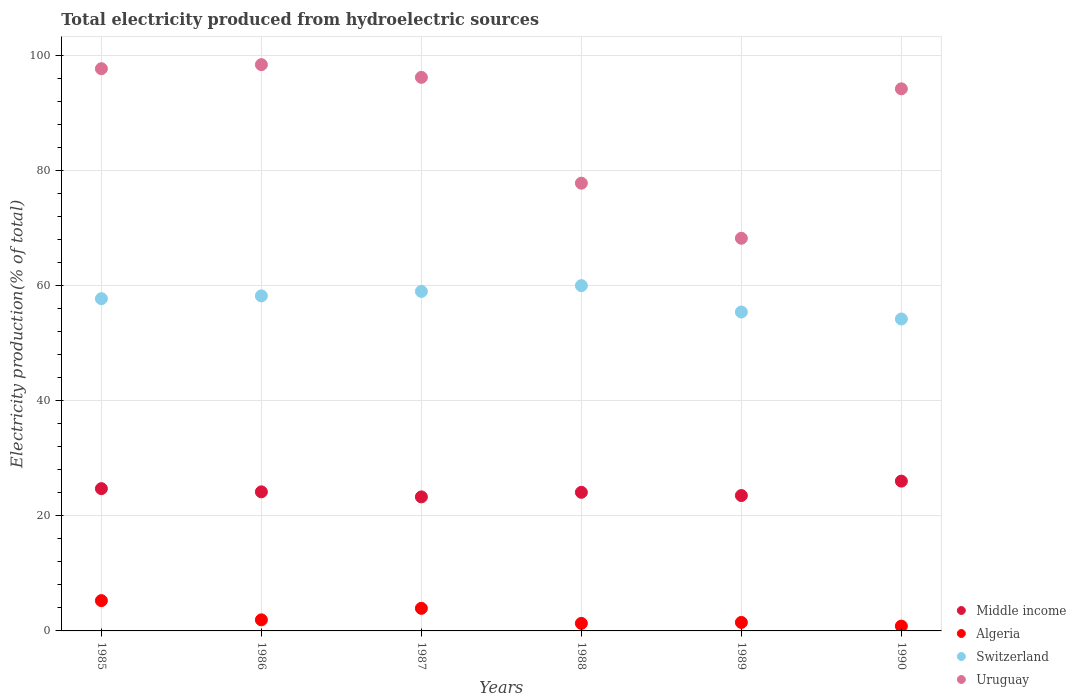What is the total electricity produced in Switzerland in 1990?
Keep it short and to the point. 54.18. Across all years, what is the maximum total electricity produced in Middle income?
Make the answer very short. 26.02. Across all years, what is the minimum total electricity produced in Switzerland?
Provide a short and direct response. 54.18. What is the total total electricity produced in Switzerland in the graph?
Your answer should be very brief. 344.41. What is the difference between the total electricity produced in Switzerland in 1986 and that in 1988?
Offer a very short reply. -1.78. What is the difference between the total electricity produced in Algeria in 1990 and the total electricity produced in Switzerland in 1987?
Offer a terse response. -58.13. What is the average total electricity produced in Switzerland per year?
Offer a very short reply. 57.4. In the year 1988, what is the difference between the total electricity produced in Uruguay and total electricity produced in Switzerland?
Ensure brevity in your answer.  17.79. In how many years, is the total electricity produced in Switzerland greater than 16 %?
Your response must be concise. 6. What is the ratio of the total electricity produced in Algeria in 1985 to that in 1990?
Give a very brief answer. 6.28. Is the difference between the total electricity produced in Uruguay in 1987 and 1990 greater than the difference between the total electricity produced in Switzerland in 1987 and 1990?
Keep it short and to the point. No. What is the difference between the highest and the second highest total electricity produced in Middle income?
Offer a very short reply. 1.31. What is the difference between the highest and the lowest total electricity produced in Uruguay?
Provide a succinct answer. 30.16. What is the difference between two consecutive major ticks on the Y-axis?
Give a very brief answer. 20. Are the values on the major ticks of Y-axis written in scientific E-notation?
Your response must be concise. No. Does the graph contain any zero values?
Give a very brief answer. No. How many legend labels are there?
Your answer should be compact. 4. How are the legend labels stacked?
Your answer should be very brief. Vertical. What is the title of the graph?
Offer a terse response. Total electricity produced from hydroelectric sources. Does "Serbia" appear as one of the legend labels in the graph?
Your answer should be very brief. No. What is the label or title of the X-axis?
Your response must be concise. Years. What is the Electricity production(% of total) of Middle income in 1985?
Provide a short and direct response. 24.71. What is the Electricity production(% of total) of Algeria in 1985?
Your answer should be compact. 5.26. What is the Electricity production(% of total) in Switzerland in 1985?
Your answer should be compact. 57.71. What is the Electricity production(% of total) in Uruguay in 1985?
Offer a terse response. 97.65. What is the Electricity production(% of total) in Middle income in 1986?
Make the answer very short. 24.16. What is the Electricity production(% of total) in Algeria in 1986?
Ensure brevity in your answer.  1.93. What is the Electricity production(% of total) in Switzerland in 1986?
Offer a very short reply. 58.19. What is the Electricity production(% of total) in Uruguay in 1986?
Offer a terse response. 98.35. What is the Electricity production(% of total) in Middle income in 1987?
Provide a succinct answer. 23.28. What is the Electricity production(% of total) in Algeria in 1987?
Provide a short and direct response. 3.92. What is the Electricity production(% of total) in Switzerland in 1987?
Keep it short and to the point. 58.97. What is the Electricity production(% of total) in Uruguay in 1987?
Offer a terse response. 96.15. What is the Electricity production(% of total) of Middle income in 1988?
Your answer should be compact. 24.07. What is the Electricity production(% of total) in Algeria in 1988?
Make the answer very short. 1.31. What is the Electricity production(% of total) in Switzerland in 1988?
Your response must be concise. 59.97. What is the Electricity production(% of total) of Uruguay in 1988?
Provide a short and direct response. 77.77. What is the Electricity production(% of total) of Middle income in 1989?
Make the answer very short. 23.51. What is the Electricity production(% of total) of Algeria in 1989?
Offer a very short reply. 1.47. What is the Electricity production(% of total) in Switzerland in 1989?
Keep it short and to the point. 55.39. What is the Electricity production(% of total) of Uruguay in 1989?
Keep it short and to the point. 68.2. What is the Electricity production(% of total) in Middle income in 1990?
Give a very brief answer. 26.02. What is the Electricity production(% of total) in Algeria in 1990?
Give a very brief answer. 0.84. What is the Electricity production(% of total) of Switzerland in 1990?
Keep it short and to the point. 54.18. What is the Electricity production(% of total) of Uruguay in 1990?
Make the answer very short. 94.16. Across all years, what is the maximum Electricity production(% of total) of Middle income?
Make the answer very short. 26.02. Across all years, what is the maximum Electricity production(% of total) in Algeria?
Ensure brevity in your answer.  5.26. Across all years, what is the maximum Electricity production(% of total) of Switzerland?
Provide a short and direct response. 59.97. Across all years, what is the maximum Electricity production(% of total) of Uruguay?
Keep it short and to the point. 98.35. Across all years, what is the minimum Electricity production(% of total) in Middle income?
Provide a succinct answer. 23.28. Across all years, what is the minimum Electricity production(% of total) in Algeria?
Offer a terse response. 0.84. Across all years, what is the minimum Electricity production(% of total) of Switzerland?
Offer a very short reply. 54.18. Across all years, what is the minimum Electricity production(% of total) in Uruguay?
Your answer should be compact. 68.2. What is the total Electricity production(% of total) of Middle income in the graph?
Your answer should be very brief. 145.76. What is the total Electricity production(% of total) of Algeria in the graph?
Your answer should be very brief. 14.73. What is the total Electricity production(% of total) of Switzerland in the graph?
Keep it short and to the point. 344.41. What is the total Electricity production(% of total) in Uruguay in the graph?
Your response must be concise. 532.28. What is the difference between the Electricity production(% of total) of Middle income in 1985 and that in 1986?
Make the answer very short. 0.56. What is the difference between the Electricity production(% of total) in Algeria in 1985 and that in 1986?
Offer a very short reply. 3.34. What is the difference between the Electricity production(% of total) of Switzerland in 1985 and that in 1986?
Provide a succinct answer. -0.48. What is the difference between the Electricity production(% of total) of Uruguay in 1985 and that in 1986?
Offer a very short reply. -0.7. What is the difference between the Electricity production(% of total) in Middle income in 1985 and that in 1987?
Offer a terse response. 1.43. What is the difference between the Electricity production(% of total) in Algeria in 1985 and that in 1987?
Offer a terse response. 1.34. What is the difference between the Electricity production(% of total) in Switzerland in 1985 and that in 1987?
Give a very brief answer. -1.26. What is the difference between the Electricity production(% of total) in Uruguay in 1985 and that in 1987?
Offer a very short reply. 1.51. What is the difference between the Electricity production(% of total) in Middle income in 1985 and that in 1988?
Your answer should be very brief. 0.64. What is the difference between the Electricity production(% of total) of Algeria in 1985 and that in 1988?
Keep it short and to the point. 3.95. What is the difference between the Electricity production(% of total) of Switzerland in 1985 and that in 1988?
Make the answer very short. -2.27. What is the difference between the Electricity production(% of total) of Uruguay in 1985 and that in 1988?
Ensure brevity in your answer.  19.89. What is the difference between the Electricity production(% of total) of Middle income in 1985 and that in 1989?
Offer a very short reply. 1.2. What is the difference between the Electricity production(% of total) of Algeria in 1985 and that in 1989?
Ensure brevity in your answer.  3.79. What is the difference between the Electricity production(% of total) in Switzerland in 1985 and that in 1989?
Your answer should be compact. 2.32. What is the difference between the Electricity production(% of total) in Uruguay in 1985 and that in 1989?
Offer a terse response. 29.46. What is the difference between the Electricity production(% of total) of Middle income in 1985 and that in 1990?
Offer a very short reply. -1.31. What is the difference between the Electricity production(% of total) of Algeria in 1985 and that in 1990?
Give a very brief answer. 4.42. What is the difference between the Electricity production(% of total) in Switzerland in 1985 and that in 1990?
Keep it short and to the point. 3.53. What is the difference between the Electricity production(% of total) of Uruguay in 1985 and that in 1990?
Offer a very short reply. 3.5. What is the difference between the Electricity production(% of total) in Middle income in 1986 and that in 1987?
Your answer should be compact. 0.88. What is the difference between the Electricity production(% of total) of Algeria in 1986 and that in 1987?
Provide a short and direct response. -2. What is the difference between the Electricity production(% of total) of Switzerland in 1986 and that in 1987?
Provide a succinct answer. -0.78. What is the difference between the Electricity production(% of total) of Uruguay in 1986 and that in 1987?
Your answer should be compact. 2.21. What is the difference between the Electricity production(% of total) in Middle income in 1986 and that in 1988?
Your answer should be compact. 0.08. What is the difference between the Electricity production(% of total) in Algeria in 1986 and that in 1988?
Your answer should be very brief. 0.62. What is the difference between the Electricity production(% of total) of Switzerland in 1986 and that in 1988?
Your response must be concise. -1.78. What is the difference between the Electricity production(% of total) in Uruguay in 1986 and that in 1988?
Give a very brief answer. 20.59. What is the difference between the Electricity production(% of total) in Middle income in 1986 and that in 1989?
Offer a terse response. 0.64. What is the difference between the Electricity production(% of total) in Algeria in 1986 and that in 1989?
Keep it short and to the point. 0.45. What is the difference between the Electricity production(% of total) in Switzerland in 1986 and that in 1989?
Ensure brevity in your answer.  2.8. What is the difference between the Electricity production(% of total) in Uruguay in 1986 and that in 1989?
Ensure brevity in your answer.  30.16. What is the difference between the Electricity production(% of total) of Middle income in 1986 and that in 1990?
Provide a succinct answer. -1.86. What is the difference between the Electricity production(% of total) of Algeria in 1986 and that in 1990?
Provide a succinct answer. 1.09. What is the difference between the Electricity production(% of total) of Switzerland in 1986 and that in 1990?
Your response must be concise. 4.01. What is the difference between the Electricity production(% of total) in Uruguay in 1986 and that in 1990?
Offer a terse response. 4.2. What is the difference between the Electricity production(% of total) of Middle income in 1987 and that in 1988?
Offer a terse response. -0.79. What is the difference between the Electricity production(% of total) of Algeria in 1987 and that in 1988?
Provide a succinct answer. 2.61. What is the difference between the Electricity production(% of total) of Switzerland in 1987 and that in 1988?
Provide a succinct answer. -1. What is the difference between the Electricity production(% of total) of Uruguay in 1987 and that in 1988?
Make the answer very short. 18.38. What is the difference between the Electricity production(% of total) of Middle income in 1987 and that in 1989?
Keep it short and to the point. -0.23. What is the difference between the Electricity production(% of total) in Algeria in 1987 and that in 1989?
Your response must be concise. 2.45. What is the difference between the Electricity production(% of total) of Switzerland in 1987 and that in 1989?
Keep it short and to the point. 3.58. What is the difference between the Electricity production(% of total) of Uruguay in 1987 and that in 1989?
Provide a succinct answer. 27.95. What is the difference between the Electricity production(% of total) in Middle income in 1987 and that in 1990?
Your response must be concise. -2.74. What is the difference between the Electricity production(% of total) in Algeria in 1987 and that in 1990?
Provide a succinct answer. 3.08. What is the difference between the Electricity production(% of total) of Switzerland in 1987 and that in 1990?
Offer a terse response. 4.79. What is the difference between the Electricity production(% of total) of Uruguay in 1987 and that in 1990?
Keep it short and to the point. 1.99. What is the difference between the Electricity production(% of total) of Middle income in 1988 and that in 1989?
Your response must be concise. 0.56. What is the difference between the Electricity production(% of total) in Algeria in 1988 and that in 1989?
Provide a succinct answer. -0.16. What is the difference between the Electricity production(% of total) in Switzerland in 1988 and that in 1989?
Your answer should be very brief. 4.58. What is the difference between the Electricity production(% of total) of Uruguay in 1988 and that in 1989?
Make the answer very short. 9.57. What is the difference between the Electricity production(% of total) in Middle income in 1988 and that in 1990?
Ensure brevity in your answer.  -1.94. What is the difference between the Electricity production(% of total) in Algeria in 1988 and that in 1990?
Provide a short and direct response. 0.47. What is the difference between the Electricity production(% of total) of Switzerland in 1988 and that in 1990?
Keep it short and to the point. 5.79. What is the difference between the Electricity production(% of total) of Uruguay in 1988 and that in 1990?
Make the answer very short. -16.39. What is the difference between the Electricity production(% of total) in Middle income in 1989 and that in 1990?
Give a very brief answer. -2.5. What is the difference between the Electricity production(% of total) in Algeria in 1989 and that in 1990?
Make the answer very short. 0.64. What is the difference between the Electricity production(% of total) of Switzerland in 1989 and that in 1990?
Offer a terse response. 1.21. What is the difference between the Electricity production(% of total) of Uruguay in 1989 and that in 1990?
Keep it short and to the point. -25.96. What is the difference between the Electricity production(% of total) in Middle income in 1985 and the Electricity production(% of total) in Algeria in 1986?
Give a very brief answer. 22.79. What is the difference between the Electricity production(% of total) in Middle income in 1985 and the Electricity production(% of total) in Switzerland in 1986?
Your response must be concise. -33.48. What is the difference between the Electricity production(% of total) of Middle income in 1985 and the Electricity production(% of total) of Uruguay in 1986?
Give a very brief answer. -73.64. What is the difference between the Electricity production(% of total) of Algeria in 1985 and the Electricity production(% of total) of Switzerland in 1986?
Make the answer very short. -52.93. What is the difference between the Electricity production(% of total) of Algeria in 1985 and the Electricity production(% of total) of Uruguay in 1986?
Give a very brief answer. -93.09. What is the difference between the Electricity production(% of total) in Switzerland in 1985 and the Electricity production(% of total) in Uruguay in 1986?
Give a very brief answer. -40.65. What is the difference between the Electricity production(% of total) in Middle income in 1985 and the Electricity production(% of total) in Algeria in 1987?
Offer a very short reply. 20.79. What is the difference between the Electricity production(% of total) of Middle income in 1985 and the Electricity production(% of total) of Switzerland in 1987?
Keep it short and to the point. -34.26. What is the difference between the Electricity production(% of total) of Middle income in 1985 and the Electricity production(% of total) of Uruguay in 1987?
Your answer should be compact. -71.43. What is the difference between the Electricity production(% of total) in Algeria in 1985 and the Electricity production(% of total) in Switzerland in 1987?
Provide a short and direct response. -53.71. What is the difference between the Electricity production(% of total) in Algeria in 1985 and the Electricity production(% of total) in Uruguay in 1987?
Your answer should be very brief. -90.88. What is the difference between the Electricity production(% of total) of Switzerland in 1985 and the Electricity production(% of total) of Uruguay in 1987?
Your response must be concise. -38.44. What is the difference between the Electricity production(% of total) of Middle income in 1985 and the Electricity production(% of total) of Algeria in 1988?
Make the answer very short. 23.4. What is the difference between the Electricity production(% of total) in Middle income in 1985 and the Electricity production(% of total) in Switzerland in 1988?
Your answer should be compact. -35.26. What is the difference between the Electricity production(% of total) of Middle income in 1985 and the Electricity production(% of total) of Uruguay in 1988?
Provide a short and direct response. -53.05. What is the difference between the Electricity production(% of total) in Algeria in 1985 and the Electricity production(% of total) in Switzerland in 1988?
Keep it short and to the point. -54.71. What is the difference between the Electricity production(% of total) of Algeria in 1985 and the Electricity production(% of total) of Uruguay in 1988?
Your response must be concise. -72.5. What is the difference between the Electricity production(% of total) in Switzerland in 1985 and the Electricity production(% of total) in Uruguay in 1988?
Give a very brief answer. -20.06. What is the difference between the Electricity production(% of total) in Middle income in 1985 and the Electricity production(% of total) in Algeria in 1989?
Ensure brevity in your answer.  23.24. What is the difference between the Electricity production(% of total) of Middle income in 1985 and the Electricity production(% of total) of Switzerland in 1989?
Provide a succinct answer. -30.68. What is the difference between the Electricity production(% of total) of Middle income in 1985 and the Electricity production(% of total) of Uruguay in 1989?
Offer a terse response. -43.49. What is the difference between the Electricity production(% of total) in Algeria in 1985 and the Electricity production(% of total) in Switzerland in 1989?
Offer a very short reply. -50.13. What is the difference between the Electricity production(% of total) of Algeria in 1985 and the Electricity production(% of total) of Uruguay in 1989?
Ensure brevity in your answer.  -62.94. What is the difference between the Electricity production(% of total) of Switzerland in 1985 and the Electricity production(% of total) of Uruguay in 1989?
Your answer should be compact. -10.49. What is the difference between the Electricity production(% of total) in Middle income in 1985 and the Electricity production(% of total) in Algeria in 1990?
Provide a short and direct response. 23.87. What is the difference between the Electricity production(% of total) of Middle income in 1985 and the Electricity production(% of total) of Switzerland in 1990?
Offer a very short reply. -29.47. What is the difference between the Electricity production(% of total) of Middle income in 1985 and the Electricity production(% of total) of Uruguay in 1990?
Provide a succinct answer. -69.44. What is the difference between the Electricity production(% of total) of Algeria in 1985 and the Electricity production(% of total) of Switzerland in 1990?
Your answer should be very brief. -48.92. What is the difference between the Electricity production(% of total) in Algeria in 1985 and the Electricity production(% of total) in Uruguay in 1990?
Your response must be concise. -88.89. What is the difference between the Electricity production(% of total) in Switzerland in 1985 and the Electricity production(% of total) in Uruguay in 1990?
Provide a short and direct response. -36.45. What is the difference between the Electricity production(% of total) of Middle income in 1986 and the Electricity production(% of total) of Algeria in 1987?
Offer a very short reply. 20.23. What is the difference between the Electricity production(% of total) of Middle income in 1986 and the Electricity production(% of total) of Switzerland in 1987?
Give a very brief answer. -34.81. What is the difference between the Electricity production(% of total) of Middle income in 1986 and the Electricity production(% of total) of Uruguay in 1987?
Give a very brief answer. -71.99. What is the difference between the Electricity production(% of total) in Algeria in 1986 and the Electricity production(% of total) in Switzerland in 1987?
Offer a very short reply. -57.04. What is the difference between the Electricity production(% of total) of Algeria in 1986 and the Electricity production(% of total) of Uruguay in 1987?
Provide a succinct answer. -94.22. What is the difference between the Electricity production(% of total) of Switzerland in 1986 and the Electricity production(% of total) of Uruguay in 1987?
Your answer should be very brief. -37.96. What is the difference between the Electricity production(% of total) of Middle income in 1986 and the Electricity production(% of total) of Algeria in 1988?
Offer a very short reply. 22.85. What is the difference between the Electricity production(% of total) of Middle income in 1986 and the Electricity production(% of total) of Switzerland in 1988?
Your answer should be very brief. -35.82. What is the difference between the Electricity production(% of total) in Middle income in 1986 and the Electricity production(% of total) in Uruguay in 1988?
Make the answer very short. -53.61. What is the difference between the Electricity production(% of total) in Algeria in 1986 and the Electricity production(% of total) in Switzerland in 1988?
Offer a terse response. -58.05. What is the difference between the Electricity production(% of total) of Algeria in 1986 and the Electricity production(% of total) of Uruguay in 1988?
Provide a succinct answer. -75.84. What is the difference between the Electricity production(% of total) of Switzerland in 1986 and the Electricity production(% of total) of Uruguay in 1988?
Keep it short and to the point. -19.57. What is the difference between the Electricity production(% of total) of Middle income in 1986 and the Electricity production(% of total) of Algeria in 1989?
Offer a terse response. 22.68. What is the difference between the Electricity production(% of total) in Middle income in 1986 and the Electricity production(% of total) in Switzerland in 1989?
Provide a short and direct response. -31.23. What is the difference between the Electricity production(% of total) of Middle income in 1986 and the Electricity production(% of total) of Uruguay in 1989?
Make the answer very short. -44.04. What is the difference between the Electricity production(% of total) in Algeria in 1986 and the Electricity production(% of total) in Switzerland in 1989?
Provide a short and direct response. -53.46. What is the difference between the Electricity production(% of total) of Algeria in 1986 and the Electricity production(% of total) of Uruguay in 1989?
Ensure brevity in your answer.  -66.27. What is the difference between the Electricity production(% of total) in Switzerland in 1986 and the Electricity production(% of total) in Uruguay in 1989?
Your answer should be very brief. -10.01. What is the difference between the Electricity production(% of total) in Middle income in 1986 and the Electricity production(% of total) in Algeria in 1990?
Offer a very short reply. 23.32. What is the difference between the Electricity production(% of total) of Middle income in 1986 and the Electricity production(% of total) of Switzerland in 1990?
Your response must be concise. -30.02. What is the difference between the Electricity production(% of total) in Middle income in 1986 and the Electricity production(% of total) in Uruguay in 1990?
Your response must be concise. -70. What is the difference between the Electricity production(% of total) in Algeria in 1986 and the Electricity production(% of total) in Switzerland in 1990?
Keep it short and to the point. -52.25. What is the difference between the Electricity production(% of total) of Algeria in 1986 and the Electricity production(% of total) of Uruguay in 1990?
Provide a short and direct response. -92.23. What is the difference between the Electricity production(% of total) in Switzerland in 1986 and the Electricity production(% of total) in Uruguay in 1990?
Your answer should be very brief. -35.97. What is the difference between the Electricity production(% of total) of Middle income in 1987 and the Electricity production(% of total) of Algeria in 1988?
Offer a very short reply. 21.97. What is the difference between the Electricity production(% of total) in Middle income in 1987 and the Electricity production(% of total) in Switzerland in 1988?
Provide a succinct answer. -36.69. What is the difference between the Electricity production(% of total) in Middle income in 1987 and the Electricity production(% of total) in Uruguay in 1988?
Keep it short and to the point. -54.49. What is the difference between the Electricity production(% of total) in Algeria in 1987 and the Electricity production(% of total) in Switzerland in 1988?
Your response must be concise. -56.05. What is the difference between the Electricity production(% of total) in Algeria in 1987 and the Electricity production(% of total) in Uruguay in 1988?
Offer a very short reply. -73.84. What is the difference between the Electricity production(% of total) of Switzerland in 1987 and the Electricity production(% of total) of Uruguay in 1988?
Your response must be concise. -18.8. What is the difference between the Electricity production(% of total) of Middle income in 1987 and the Electricity production(% of total) of Algeria in 1989?
Ensure brevity in your answer.  21.8. What is the difference between the Electricity production(% of total) in Middle income in 1987 and the Electricity production(% of total) in Switzerland in 1989?
Give a very brief answer. -32.11. What is the difference between the Electricity production(% of total) in Middle income in 1987 and the Electricity production(% of total) in Uruguay in 1989?
Offer a terse response. -44.92. What is the difference between the Electricity production(% of total) in Algeria in 1987 and the Electricity production(% of total) in Switzerland in 1989?
Provide a short and direct response. -51.47. What is the difference between the Electricity production(% of total) in Algeria in 1987 and the Electricity production(% of total) in Uruguay in 1989?
Offer a terse response. -64.28. What is the difference between the Electricity production(% of total) in Switzerland in 1987 and the Electricity production(% of total) in Uruguay in 1989?
Keep it short and to the point. -9.23. What is the difference between the Electricity production(% of total) of Middle income in 1987 and the Electricity production(% of total) of Algeria in 1990?
Make the answer very short. 22.44. What is the difference between the Electricity production(% of total) in Middle income in 1987 and the Electricity production(% of total) in Switzerland in 1990?
Provide a succinct answer. -30.9. What is the difference between the Electricity production(% of total) in Middle income in 1987 and the Electricity production(% of total) in Uruguay in 1990?
Your response must be concise. -70.88. What is the difference between the Electricity production(% of total) of Algeria in 1987 and the Electricity production(% of total) of Switzerland in 1990?
Your answer should be very brief. -50.26. What is the difference between the Electricity production(% of total) in Algeria in 1987 and the Electricity production(% of total) in Uruguay in 1990?
Your answer should be very brief. -90.23. What is the difference between the Electricity production(% of total) in Switzerland in 1987 and the Electricity production(% of total) in Uruguay in 1990?
Make the answer very short. -35.19. What is the difference between the Electricity production(% of total) of Middle income in 1988 and the Electricity production(% of total) of Algeria in 1989?
Offer a terse response. 22.6. What is the difference between the Electricity production(% of total) in Middle income in 1988 and the Electricity production(% of total) in Switzerland in 1989?
Make the answer very short. -31.32. What is the difference between the Electricity production(% of total) in Middle income in 1988 and the Electricity production(% of total) in Uruguay in 1989?
Give a very brief answer. -44.12. What is the difference between the Electricity production(% of total) in Algeria in 1988 and the Electricity production(% of total) in Switzerland in 1989?
Your answer should be very brief. -54.08. What is the difference between the Electricity production(% of total) in Algeria in 1988 and the Electricity production(% of total) in Uruguay in 1989?
Offer a very short reply. -66.89. What is the difference between the Electricity production(% of total) in Switzerland in 1988 and the Electricity production(% of total) in Uruguay in 1989?
Keep it short and to the point. -8.22. What is the difference between the Electricity production(% of total) of Middle income in 1988 and the Electricity production(% of total) of Algeria in 1990?
Provide a succinct answer. 23.24. What is the difference between the Electricity production(% of total) in Middle income in 1988 and the Electricity production(% of total) in Switzerland in 1990?
Offer a very short reply. -30.1. What is the difference between the Electricity production(% of total) in Middle income in 1988 and the Electricity production(% of total) in Uruguay in 1990?
Make the answer very short. -70.08. What is the difference between the Electricity production(% of total) in Algeria in 1988 and the Electricity production(% of total) in Switzerland in 1990?
Offer a terse response. -52.87. What is the difference between the Electricity production(% of total) in Algeria in 1988 and the Electricity production(% of total) in Uruguay in 1990?
Offer a terse response. -92.85. What is the difference between the Electricity production(% of total) of Switzerland in 1988 and the Electricity production(% of total) of Uruguay in 1990?
Provide a short and direct response. -34.18. What is the difference between the Electricity production(% of total) in Middle income in 1989 and the Electricity production(% of total) in Algeria in 1990?
Offer a very short reply. 22.68. What is the difference between the Electricity production(% of total) in Middle income in 1989 and the Electricity production(% of total) in Switzerland in 1990?
Your answer should be compact. -30.66. What is the difference between the Electricity production(% of total) of Middle income in 1989 and the Electricity production(% of total) of Uruguay in 1990?
Provide a succinct answer. -70.64. What is the difference between the Electricity production(% of total) in Algeria in 1989 and the Electricity production(% of total) in Switzerland in 1990?
Provide a short and direct response. -52.7. What is the difference between the Electricity production(% of total) in Algeria in 1989 and the Electricity production(% of total) in Uruguay in 1990?
Your response must be concise. -92.68. What is the difference between the Electricity production(% of total) of Switzerland in 1989 and the Electricity production(% of total) of Uruguay in 1990?
Your answer should be very brief. -38.77. What is the average Electricity production(% of total) of Middle income per year?
Offer a very short reply. 24.29. What is the average Electricity production(% of total) of Algeria per year?
Give a very brief answer. 2.46. What is the average Electricity production(% of total) of Switzerland per year?
Provide a short and direct response. 57.4. What is the average Electricity production(% of total) in Uruguay per year?
Provide a short and direct response. 88.71. In the year 1985, what is the difference between the Electricity production(% of total) in Middle income and Electricity production(% of total) in Algeria?
Offer a terse response. 19.45. In the year 1985, what is the difference between the Electricity production(% of total) in Middle income and Electricity production(% of total) in Switzerland?
Ensure brevity in your answer.  -32.99. In the year 1985, what is the difference between the Electricity production(% of total) in Middle income and Electricity production(% of total) in Uruguay?
Make the answer very short. -72.94. In the year 1985, what is the difference between the Electricity production(% of total) of Algeria and Electricity production(% of total) of Switzerland?
Your answer should be very brief. -52.44. In the year 1985, what is the difference between the Electricity production(% of total) of Algeria and Electricity production(% of total) of Uruguay?
Your answer should be compact. -92.39. In the year 1985, what is the difference between the Electricity production(% of total) of Switzerland and Electricity production(% of total) of Uruguay?
Provide a succinct answer. -39.95. In the year 1986, what is the difference between the Electricity production(% of total) of Middle income and Electricity production(% of total) of Algeria?
Give a very brief answer. 22.23. In the year 1986, what is the difference between the Electricity production(% of total) of Middle income and Electricity production(% of total) of Switzerland?
Give a very brief answer. -34.03. In the year 1986, what is the difference between the Electricity production(% of total) in Middle income and Electricity production(% of total) in Uruguay?
Make the answer very short. -74.2. In the year 1986, what is the difference between the Electricity production(% of total) in Algeria and Electricity production(% of total) in Switzerland?
Make the answer very short. -56.27. In the year 1986, what is the difference between the Electricity production(% of total) in Algeria and Electricity production(% of total) in Uruguay?
Give a very brief answer. -96.43. In the year 1986, what is the difference between the Electricity production(% of total) of Switzerland and Electricity production(% of total) of Uruguay?
Keep it short and to the point. -40.16. In the year 1987, what is the difference between the Electricity production(% of total) of Middle income and Electricity production(% of total) of Algeria?
Your response must be concise. 19.36. In the year 1987, what is the difference between the Electricity production(% of total) of Middle income and Electricity production(% of total) of Switzerland?
Your response must be concise. -35.69. In the year 1987, what is the difference between the Electricity production(% of total) in Middle income and Electricity production(% of total) in Uruguay?
Offer a terse response. -72.87. In the year 1987, what is the difference between the Electricity production(% of total) of Algeria and Electricity production(% of total) of Switzerland?
Your answer should be compact. -55.05. In the year 1987, what is the difference between the Electricity production(% of total) in Algeria and Electricity production(% of total) in Uruguay?
Give a very brief answer. -92.23. In the year 1987, what is the difference between the Electricity production(% of total) of Switzerland and Electricity production(% of total) of Uruguay?
Your response must be concise. -37.18. In the year 1988, what is the difference between the Electricity production(% of total) of Middle income and Electricity production(% of total) of Algeria?
Make the answer very short. 22.76. In the year 1988, what is the difference between the Electricity production(% of total) of Middle income and Electricity production(% of total) of Switzerland?
Provide a short and direct response. -35.9. In the year 1988, what is the difference between the Electricity production(% of total) in Middle income and Electricity production(% of total) in Uruguay?
Offer a terse response. -53.69. In the year 1988, what is the difference between the Electricity production(% of total) of Algeria and Electricity production(% of total) of Switzerland?
Make the answer very short. -58.66. In the year 1988, what is the difference between the Electricity production(% of total) of Algeria and Electricity production(% of total) of Uruguay?
Ensure brevity in your answer.  -76.45. In the year 1988, what is the difference between the Electricity production(% of total) of Switzerland and Electricity production(% of total) of Uruguay?
Offer a terse response. -17.79. In the year 1989, what is the difference between the Electricity production(% of total) in Middle income and Electricity production(% of total) in Algeria?
Ensure brevity in your answer.  22.04. In the year 1989, what is the difference between the Electricity production(% of total) in Middle income and Electricity production(% of total) in Switzerland?
Your response must be concise. -31.88. In the year 1989, what is the difference between the Electricity production(% of total) of Middle income and Electricity production(% of total) of Uruguay?
Your answer should be compact. -44.68. In the year 1989, what is the difference between the Electricity production(% of total) of Algeria and Electricity production(% of total) of Switzerland?
Ensure brevity in your answer.  -53.92. In the year 1989, what is the difference between the Electricity production(% of total) in Algeria and Electricity production(% of total) in Uruguay?
Your answer should be compact. -66.72. In the year 1989, what is the difference between the Electricity production(% of total) of Switzerland and Electricity production(% of total) of Uruguay?
Keep it short and to the point. -12.81. In the year 1990, what is the difference between the Electricity production(% of total) in Middle income and Electricity production(% of total) in Algeria?
Your response must be concise. 25.18. In the year 1990, what is the difference between the Electricity production(% of total) in Middle income and Electricity production(% of total) in Switzerland?
Provide a short and direct response. -28.16. In the year 1990, what is the difference between the Electricity production(% of total) in Middle income and Electricity production(% of total) in Uruguay?
Offer a very short reply. -68.14. In the year 1990, what is the difference between the Electricity production(% of total) in Algeria and Electricity production(% of total) in Switzerland?
Keep it short and to the point. -53.34. In the year 1990, what is the difference between the Electricity production(% of total) in Algeria and Electricity production(% of total) in Uruguay?
Your answer should be compact. -93.32. In the year 1990, what is the difference between the Electricity production(% of total) of Switzerland and Electricity production(% of total) of Uruguay?
Ensure brevity in your answer.  -39.98. What is the ratio of the Electricity production(% of total) in Middle income in 1985 to that in 1986?
Make the answer very short. 1.02. What is the ratio of the Electricity production(% of total) in Algeria in 1985 to that in 1986?
Provide a short and direct response. 2.73. What is the ratio of the Electricity production(% of total) in Middle income in 1985 to that in 1987?
Provide a succinct answer. 1.06. What is the ratio of the Electricity production(% of total) in Algeria in 1985 to that in 1987?
Provide a succinct answer. 1.34. What is the ratio of the Electricity production(% of total) of Switzerland in 1985 to that in 1987?
Offer a terse response. 0.98. What is the ratio of the Electricity production(% of total) in Uruguay in 1985 to that in 1987?
Offer a very short reply. 1.02. What is the ratio of the Electricity production(% of total) in Middle income in 1985 to that in 1988?
Ensure brevity in your answer.  1.03. What is the ratio of the Electricity production(% of total) of Algeria in 1985 to that in 1988?
Ensure brevity in your answer.  4.02. What is the ratio of the Electricity production(% of total) of Switzerland in 1985 to that in 1988?
Provide a short and direct response. 0.96. What is the ratio of the Electricity production(% of total) of Uruguay in 1985 to that in 1988?
Give a very brief answer. 1.26. What is the ratio of the Electricity production(% of total) in Middle income in 1985 to that in 1989?
Your answer should be compact. 1.05. What is the ratio of the Electricity production(% of total) of Algeria in 1985 to that in 1989?
Ensure brevity in your answer.  3.57. What is the ratio of the Electricity production(% of total) in Switzerland in 1985 to that in 1989?
Provide a short and direct response. 1.04. What is the ratio of the Electricity production(% of total) of Uruguay in 1985 to that in 1989?
Provide a short and direct response. 1.43. What is the ratio of the Electricity production(% of total) of Middle income in 1985 to that in 1990?
Provide a succinct answer. 0.95. What is the ratio of the Electricity production(% of total) of Algeria in 1985 to that in 1990?
Offer a terse response. 6.28. What is the ratio of the Electricity production(% of total) in Switzerland in 1985 to that in 1990?
Your answer should be compact. 1.07. What is the ratio of the Electricity production(% of total) of Uruguay in 1985 to that in 1990?
Your response must be concise. 1.04. What is the ratio of the Electricity production(% of total) in Middle income in 1986 to that in 1987?
Keep it short and to the point. 1.04. What is the ratio of the Electricity production(% of total) in Algeria in 1986 to that in 1987?
Give a very brief answer. 0.49. What is the ratio of the Electricity production(% of total) in Middle income in 1986 to that in 1988?
Provide a succinct answer. 1. What is the ratio of the Electricity production(% of total) in Algeria in 1986 to that in 1988?
Provide a succinct answer. 1.47. What is the ratio of the Electricity production(% of total) of Switzerland in 1986 to that in 1988?
Offer a terse response. 0.97. What is the ratio of the Electricity production(% of total) of Uruguay in 1986 to that in 1988?
Provide a short and direct response. 1.26. What is the ratio of the Electricity production(% of total) of Middle income in 1986 to that in 1989?
Offer a very short reply. 1.03. What is the ratio of the Electricity production(% of total) in Algeria in 1986 to that in 1989?
Keep it short and to the point. 1.31. What is the ratio of the Electricity production(% of total) in Switzerland in 1986 to that in 1989?
Provide a succinct answer. 1.05. What is the ratio of the Electricity production(% of total) in Uruguay in 1986 to that in 1989?
Your answer should be very brief. 1.44. What is the ratio of the Electricity production(% of total) of Middle income in 1986 to that in 1990?
Keep it short and to the point. 0.93. What is the ratio of the Electricity production(% of total) in Algeria in 1986 to that in 1990?
Keep it short and to the point. 2.3. What is the ratio of the Electricity production(% of total) in Switzerland in 1986 to that in 1990?
Offer a terse response. 1.07. What is the ratio of the Electricity production(% of total) of Uruguay in 1986 to that in 1990?
Ensure brevity in your answer.  1.04. What is the ratio of the Electricity production(% of total) of Algeria in 1987 to that in 1988?
Provide a short and direct response. 2.99. What is the ratio of the Electricity production(% of total) in Switzerland in 1987 to that in 1988?
Your answer should be very brief. 0.98. What is the ratio of the Electricity production(% of total) in Uruguay in 1987 to that in 1988?
Provide a succinct answer. 1.24. What is the ratio of the Electricity production(% of total) in Algeria in 1987 to that in 1989?
Your answer should be compact. 2.66. What is the ratio of the Electricity production(% of total) of Switzerland in 1987 to that in 1989?
Ensure brevity in your answer.  1.06. What is the ratio of the Electricity production(% of total) in Uruguay in 1987 to that in 1989?
Your response must be concise. 1.41. What is the ratio of the Electricity production(% of total) in Middle income in 1987 to that in 1990?
Offer a terse response. 0.89. What is the ratio of the Electricity production(% of total) in Algeria in 1987 to that in 1990?
Your response must be concise. 4.68. What is the ratio of the Electricity production(% of total) in Switzerland in 1987 to that in 1990?
Ensure brevity in your answer.  1.09. What is the ratio of the Electricity production(% of total) in Uruguay in 1987 to that in 1990?
Offer a very short reply. 1.02. What is the ratio of the Electricity production(% of total) of Middle income in 1988 to that in 1989?
Make the answer very short. 1.02. What is the ratio of the Electricity production(% of total) in Algeria in 1988 to that in 1989?
Keep it short and to the point. 0.89. What is the ratio of the Electricity production(% of total) in Switzerland in 1988 to that in 1989?
Keep it short and to the point. 1.08. What is the ratio of the Electricity production(% of total) in Uruguay in 1988 to that in 1989?
Give a very brief answer. 1.14. What is the ratio of the Electricity production(% of total) in Middle income in 1988 to that in 1990?
Your answer should be compact. 0.93. What is the ratio of the Electricity production(% of total) in Algeria in 1988 to that in 1990?
Give a very brief answer. 1.56. What is the ratio of the Electricity production(% of total) of Switzerland in 1988 to that in 1990?
Ensure brevity in your answer.  1.11. What is the ratio of the Electricity production(% of total) in Uruguay in 1988 to that in 1990?
Keep it short and to the point. 0.83. What is the ratio of the Electricity production(% of total) of Middle income in 1989 to that in 1990?
Provide a short and direct response. 0.9. What is the ratio of the Electricity production(% of total) in Algeria in 1989 to that in 1990?
Ensure brevity in your answer.  1.76. What is the ratio of the Electricity production(% of total) in Switzerland in 1989 to that in 1990?
Your response must be concise. 1.02. What is the ratio of the Electricity production(% of total) of Uruguay in 1989 to that in 1990?
Offer a very short reply. 0.72. What is the difference between the highest and the second highest Electricity production(% of total) of Middle income?
Give a very brief answer. 1.31. What is the difference between the highest and the second highest Electricity production(% of total) of Algeria?
Make the answer very short. 1.34. What is the difference between the highest and the second highest Electricity production(% of total) of Uruguay?
Offer a terse response. 0.7. What is the difference between the highest and the lowest Electricity production(% of total) in Middle income?
Give a very brief answer. 2.74. What is the difference between the highest and the lowest Electricity production(% of total) in Algeria?
Make the answer very short. 4.42. What is the difference between the highest and the lowest Electricity production(% of total) in Switzerland?
Ensure brevity in your answer.  5.79. What is the difference between the highest and the lowest Electricity production(% of total) of Uruguay?
Offer a very short reply. 30.16. 